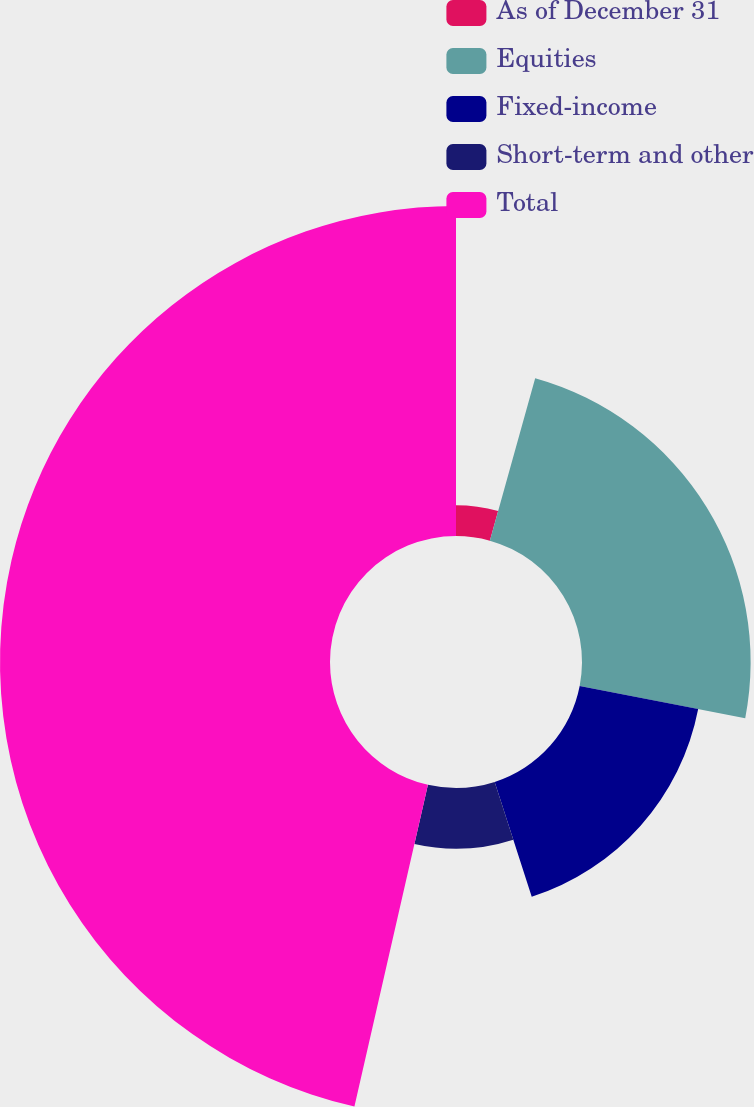Convert chart. <chart><loc_0><loc_0><loc_500><loc_500><pie_chart><fcel>As of December 31<fcel>Equities<fcel>Fixed-income<fcel>Short-term and other<fcel>Total<nl><fcel>4.33%<fcel>23.72%<fcel>16.98%<fcel>8.54%<fcel>46.42%<nl></chart> 